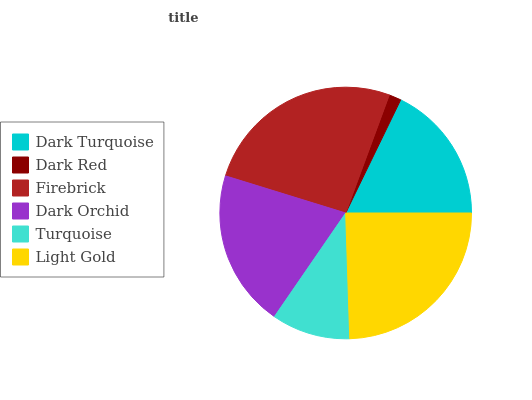Is Dark Red the minimum?
Answer yes or no. Yes. Is Firebrick the maximum?
Answer yes or no. Yes. Is Firebrick the minimum?
Answer yes or no. No. Is Dark Red the maximum?
Answer yes or no. No. Is Firebrick greater than Dark Red?
Answer yes or no. Yes. Is Dark Red less than Firebrick?
Answer yes or no. Yes. Is Dark Red greater than Firebrick?
Answer yes or no. No. Is Firebrick less than Dark Red?
Answer yes or no. No. Is Dark Orchid the high median?
Answer yes or no. Yes. Is Dark Turquoise the low median?
Answer yes or no. Yes. Is Dark Red the high median?
Answer yes or no. No. Is Turquoise the low median?
Answer yes or no. No. 